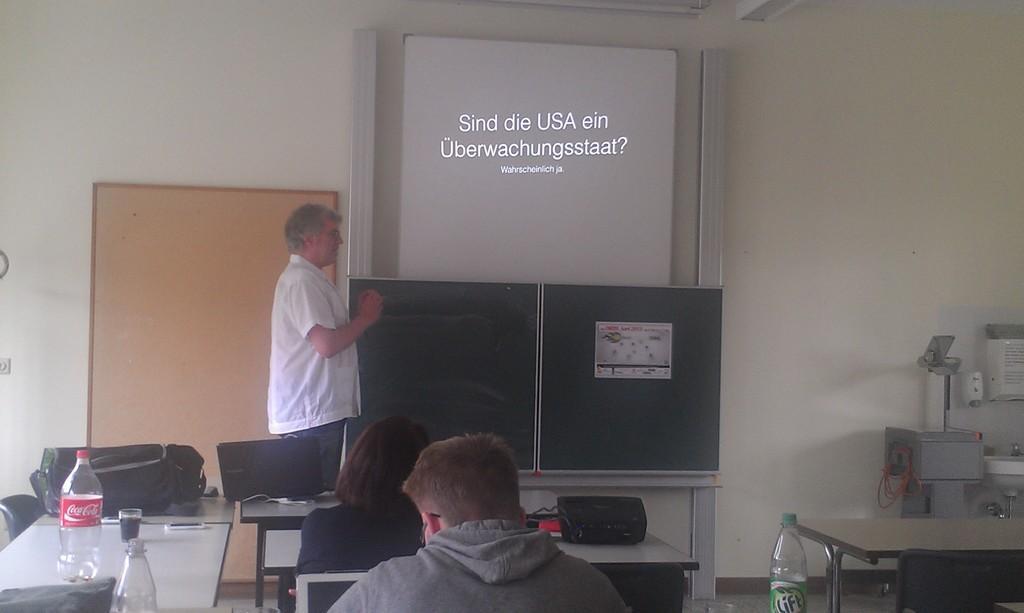How would you summarize this image in a sentence or two? In this image i can see 2 persons sitting on chairs and a person standing. In the background i can see the wall, few objects and a board. 